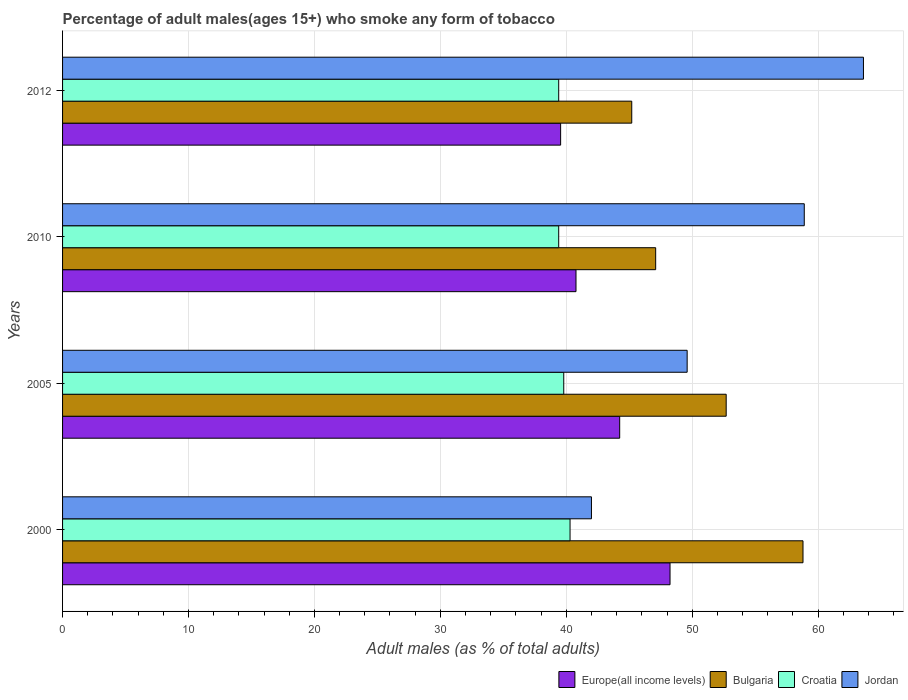How many different coloured bars are there?
Your answer should be very brief. 4. How many groups of bars are there?
Keep it short and to the point. 4. Are the number of bars per tick equal to the number of legend labels?
Your answer should be very brief. Yes. How many bars are there on the 4th tick from the bottom?
Your answer should be very brief. 4. What is the label of the 4th group of bars from the top?
Offer a terse response. 2000. In how many cases, is the number of bars for a given year not equal to the number of legend labels?
Ensure brevity in your answer.  0. What is the percentage of adult males who smoke in Bulgaria in 2000?
Keep it short and to the point. 58.8. Across all years, what is the maximum percentage of adult males who smoke in Europe(all income levels)?
Provide a short and direct response. 48.24. Across all years, what is the minimum percentage of adult males who smoke in Europe(all income levels)?
Provide a succinct answer. 39.55. In which year was the percentage of adult males who smoke in Croatia maximum?
Give a very brief answer. 2000. What is the total percentage of adult males who smoke in Jordan in the graph?
Offer a terse response. 214.1. What is the difference between the percentage of adult males who smoke in Bulgaria in 2005 and that in 2010?
Offer a very short reply. 5.6. What is the difference between the percentage of adult males who smoke in Jordan in 2010 and the percentage of adult males who smoke in Europe(all income levels) in 2005?
Give a very brief answer. 14.66. What is the average percentage of adult males who smoke in Europe(all income levels) per year?
Ensure brevity in your answer.  43.2. In the year 2005, what is the difference between the percentage of adult males who smoke in Bulgaria and percentage of adult males who smoke in Jordan?
Your answer should be very brief. 3.1. In how many years, is the percentage of adult males who smoke in Jordan greater than 60 %?
Your answer should be compact. 1. What is the ratio of the percentage of adult males who smoke in Europe(all income levels) in 2000 to that in 2012?
Your answer should be very brief. 1.22. Is the difference between the percentage of adult males who smoke in Bulgaria in 2000 and 2005 greater than the difference between the percentage of adult males who smoke in Jordan in 2000 and 2005?
Your answer should be very brief. Yes. What is the difference between the highest and the lowest percentage of adult males who smoke in Bulgaria?
Your answer should be compact. 13.6. In how many years, is the percentage of adult males who smoke in Bulgaria greater than the average percentage of adult males who smoke in Bulgaria taken over all years?
Offer a very short reply. 2. Is the sum of the percentage of adult males who smoke in Croatia in 2000 and 2005 greater than the maximum percentage of adult males who smoke in Jordan across all years?
Provide a succinct answer. Yes. Is it the case that in every year, the sum of the percentage of adult males who smoke in Jordan and percentage of adult males who smoke in Croatia is greater than the sum of percentage of adult males who smoke in Europe(all income levels) and percentage of adult males who smoke in Bulgaria?
Your answer should be compact. No. What does the 4th bar from the bottom in 2012 represents?
Your response must be concise. Jordan. Are all the bars in the graph horizontal?
Provide a succinct answer. Yes. How many legend labels are there?
Your response must be concise. 4. How are the legend labels stacked?
Offer a terse response. Horizontal. What is the title of the graph?
Your answer should be very brief. Percentage of adult males(ages 15+) who smoke any form of tobacco. Does "New Zealand" appear as one of the legend labels in the graph?
Your answer should be compact. No. What is the label or title of the X-axis?
Your answer should be very brief. Adult males (as % of total adults). What is the Adult males (as % of total adults) in Europe(all income levels) in 2000?
Your answer should be compact. 48.24. What is the Adult males (as % of total adults) in Bulgaria in 2000?
Your answer should be compact. 58.8. What is the Adult males (as % of total adults) in Croatia in 2000?
Your answer should be compact. 40.3. What is the Adult males (as % of total adults) in Jordan in 2000?
Offer a very short reply. 42. What is the Adult males (as % of total adults) of Europe(all income levels) in 2005?
Keep it short and to the point. 44.24. What is the Adult males (as % of total adults) in Bulgaria in 2005?
Provide a short and direct response. 52.7. What is the Adult males (as % of total adults) of Croatia in 2005?
Keep it short and to the point. 39.8. What is the Adult males (as % of total adults) in Jordan in 2005?
Offer a terse response. 49.6. What is the Adult males (as % of total adults) of Europe(all income levels) in 2010?
Your answer should be very brief. 40.77. What is the Adult males (as % of total adults) in Bulgaria in 2010?
Offer a terse response. 47.1. What is the Adult males (as % of total adults) of Croatia in 2010?
Provide a short and direct response. 39.4. What is the Adult males (as % of total adults) in Jordan in 2010?
Provide a short and direct response. 58.9. What is the Adult males (as % of total adults) of Europe(all income levels) in 2012?
Ensure brevity in your answer.  39.55. What is the Adult males (as % of total adults) in Bulgaria in 2012?
Ensure brevity in your answer.  45.2. What is the Adult males (as % of total adults) in Croatia in 2012?
Make the answer very short. 39.4. What is the Adult males (as % of total adults) of Jordan in 2012?
Keep it short and to the point. 63.6. Across all years, what is the maximum Adult males (as % of total adults) of Europe(all income levels)?
Offer a very short reply. 48.24. Across all years, what is the maximum Adult males (as % of total adults) of Bulgaria?
Provide a succinct answer. 58.8. Across all years, what is the maximum Adult males (as % of total adults) of Croatia?
Ensure brevity in your answer.  40.3. Across all years, what is the maximum Adult males (as % of total adults) of Jordan?
Ensure brevity in your answer.  63.6. Across all years, what is the minimum Adult males (as % of total adults) of Europe(all income levels)?
Your answer should be compact. 39.55. Across all years, what is the minimum Adult males (as % of total adults) in Bulgaria?
Give a very brief answer. 45.2. Across all years, what is the minimum Adult males (as % of total adults) in Croatia?
Your answer should be compact. 39.4. Across all years, what is the minimum Adult males (as % of total adults) of Jordan?
Keep it short and to the point. 42. What is the total Adult males (as % of total adults) of Europe(all income levels) in the graph?
Keep it short and to the point. 172.81. What is the total Adult males (as % of total adults) of Bulgaria in the graph?
Your answer should be very brief. 203.8. What is the total Adult males (as % of total adults) of Croatia in the graph?
Provide a short and direct response. 158.9. What is the total Adult males (as % of total adults) of Jordan in the graph?
Give a very brief answer. 214.1. What is the difference between the Adult males (as % of total adults) in Europe(all income levels) in 2000 and that in 2005?
Offer a terse response. 4. What is the difference between the Adult males (as % of total adults) in Bulgaria in 2000 and that in 2005?
Your answer should be very brief. 6.1. What is the difference between the Adult males (as % of total adults) of Croatia in 2000 and that in 2005?
Your answer should be compact. 0.5. What is the difference between the Adult males (as % of total adults) in Europe(all income levels) in 2000 and that in 2010?
Give a very brief answer. 7.47. What is the difference between the Adult males (as % of total adults) in Jordan in 2000 and that in 2010?
Offer a very short reply. -16.9. What is the difference between the Adult males (as % of total adults) in Europe(all income levels) in 2000 and that in 2012?
Your answer should be compact. 8.69. What is the difference between the Adult males (as % of total adults) of Jordan in 2000 and that in 2012?
Your response must be concise. -21.6. What is the difference between the Adult males (as % of total adults) of Europe(all income levels) in 2005 and that in 2010?
Make the answer very short. 3.47. What is the difference between the Adult males (as % of total adults) in Bulgaria in 2005 and that in 2010?
Your response must be concise. 5.6. What is the difference between the Adult males (as % of total adults) of Jordan in 2005 and that in 2010?
Give a very brief answer. -9.3. What is the difference between the Adult males (as % of total adults) in Europe(all income levels) in 2005 and that in 2012?
Make the answer very short. 4.69. What is the difference between the Adult males (as % of total adults) in Bulgaria in 2005 and that in 2012?
Provide a short and direct response. 7.5. What is the difference between the Adult males (as % of total adults) in Croatia in 2005 and that in 2012?
Your response must be concise. 0.4. What is the difference between the Adult males (as % of total adults) in Jordan in 2005 and that in 2012?
Provide a succinct answer. -14. What is the difference between the Adult males (as % of total adults) of Europe(all income levels) in 2010 and that in 2012?
Make the answer very short. 1.22. What is the difference between the Adult males (as % of total adults) in Croatia in 2010 and that in 2012?
Your answer should be compact. 0. What is the difference between the Adult males (as % of total adults) of Europe(all income levels) in 2000 and the Adult males (as % of total adults) of Bulgaria in 2005?
Ensure brevity in your answer.  -4.46. What is the difference between the Adult males (as % of total adults) in Europe(all income levels) in 2000 and the Adult males (as % of total adults) in Croatia in 2005?
Your answer should be very brief. 8.44. What is the difference between the Adult males (as % of total adults) in Europe(all income levels) in 2000 and the Adult males (as % of total adults) in Jordan in 2005?
Offer a very short reply. -1.36. What is the difference between the Adult males (as % of total adults) of Bulgaria in 2000 and the Adult males (as % of total adults) of Jordan in 2005?
Provide a succinct answer. 9.2. What is the difference between the Adult males (as % of total adults) of Croatia in 2000 and the Adult males (as % of total adults) of Jordan in 2005?
Keep it short and to the point. -9.3. What is the difference between the Adult males (as % of total adults) in Europe(all income levels) in 2000 and the Adult males (as % of total adults) in Bulgaria in 2010?
Ensure brevity in your answer.  1.14. What is the difference between the Adult males (as % of total adults) of Europe(all income levels) in 2000 and the Adult males (as % of total adults) of Croatia in 2010?
Ensure brevity in your answer.  8.84. What is the difference between the Adult males (as % of total adults) in Europe(all income levels) in 2000 and the Adult males (as % of total adults) in Jordan in 2010?
Offer a terse response. -10.66. What is the difference between the Adult males (as % of total adults) in Bulgaria in 2000 and the Adult males (as % of total adults) in Croatia in 2010?
Provide a succinct answer. 19.4. What is the difference between the Adult males (as % of total adults) of Bulgaria in 2000 and the Adult males (as % of total adults) of Jordan in 2010?
Keep it short and to the point. -0.1. What is the difference between the Adult males (as % of total adults) in Croatia in 2000 and the Adult males (as % of total adults) in Jordan in 2010?
Offer a very short reply. -18.6. What is the difference between the Adult males (as % of total adults) of Europe(all income levels) in 2000 and the Adult males (as % of total adults) of Bulgaria in 2012?
Ensure brevity in your answer.  3.04. What is the difference between the Adult males (as % of total adults) in Europe(all income levels) in 2000 and the Adult males (as % of total adults) in Croatia in 2012?
Your answer should be compact. 8.84. What is the difference between the Adult males (as % of total adults) of Europe(all income levels) in 2000 and the Adult males (as % of total adults) of Jordan in 2012?
Make the answer very short. -15.36. What is the difference between the Adult males (as % of total adults) in Bulgaria in 2000 and the Adult males (as % of total adults) in Croatia in 2012?
Make the answer very short. 19.4. What is the difference between the Adult males (as % of total adults) in Bulgaria in 2000 and the Adult males (as % of total adults) in Jordan in 2012?
Your response must be concise. -4.8. What is the difference between the Adult males (as % of total adults) in Croatia in 2000 and the Adult males (as % of total adults) in Jordan in 2012?
Your answer should be very brief. -23.3. What is the difference between the Adult males (as % of total adults) of Europe(all income levels) in 2005 and the Adult males (as % of total adults) of Bulgaria in 2010?
Make the answer very short. -2.86. What is the difference between the Adult males (as % of total adults) in Europe(all income levels) in 2005 and the Adult males (as % of total adults) in Croatia in 2010?
Provide a short and direct response. 4.84. What is the difference between the Adult males (as % of total adults) in Europe(all income levels) in 2005 and the Adult males (as % of total adults) in Jordan in 2010?
Your response must be concise. -14.66. What is the difference between the Adult males (as % of total adults) of Bulgaria in 2005 and the Adult males (as % of total adults) of Croatia in 2010?
Offer a terse response. 13.3. What is the difference between the Adult males (as % of total adults) in Bulgaria in 2005 and the Adult males (as % of total adults) in Jordan in 2010?
Your response must be concise. -6.2. What is the difference between the Adult males (as % of total adults) in Croatia in 2005 and the Adult males (as % of total adults) in Jordan in 2010?
Provide a short and direct response. -19.1. What is the difference between the Adult males (as % of total adults) in Europe(all income levels) in 2005 and the Adult males (as % of total adults) in Bulgaria in 2012?
Give a very brief answer. -0.96. What is the difference between the Adult males (as % of total adults) in Europe(all income levels) in 2005 and the Adult males (as % of total adults) in Croatia in 2012?
Offer a terse response. 4.84. What is the difference between the Adult males (as % of total adults) of Europe(all income levels) in 2005 and the Adult males (as % of total adults) of Jordan in 2012?
Offer a very short reply. -19.36. What is the difference between the Adult males (as % of total adults) in Bulgaria in 2005 and the Adult males (as % of total adults) in Croatia in 2012?
Provide a succinct answer. 13.3. What is the difference between the Adult males (as % of total adults) in Croatia in 2005 and the Adult males (as % of total adults) in Jordan in 2012?
Keep it short and to the point. -23.8. What is the difference between the Adult males (as % of total adults) in Europe(all income levels) in 2010 and the Adult males (as % of total adults) in Bulgaria in 2012?
Your response must be concise. -4.43. What is the difference between the Adult males (as % of total adults) in Europe(all income levels) in 2010 and the Adult males (as % of total adults) in Croatia in 2012?
Give a very brief answer. 1.37. What is the difference between the Adult males (as % of total adults) in Europe(all income levels) in 2010 and the Adult males (as % of total adults) in Jordan in 2012?
Provide a succinct answer. -22.83. What is the difference between the Adult males (as % of total adults) of Bulgaria in 2010 and the Adult males (as % of total adults) of Croatia in 2012?
Offer a terse response. 7.7. What is the difference between the Adult males (as % of total adults) of Bulgaria in 2010 and the Adult males (as % of total adults) of Jordan in 2012?
Offer a terse response. -16.5. What is the difference between the Adult males (as % of total adults) in Croatia in 2010 and the Adult males (as % of total adults) in Jordan in 2012?
Provide a succinct answer. -24.2. What is the average Adult males (as % of total adults) in Europe(all income levels) per year?
Keep it short and to the point. 43.2. What is the average Adult males (as % of total adults) of Bulgaria per year?
Your answer should be compact. 50.95. What is the average Adult males (as % of total adults) in Croatia per year?
Offer a very short reply. 39.73. What is the average Adult males (as % of total adults) in Jordan per year?
Your answer should be very brief. 53.52. In the year 2000, what is the difference between the Adult males (as % of total adults) in Europe(all income levels) and Adult males (as % of total adults) in Bulgaria?
Keep it short and to the point. -10.56. In the year 2000, what is the difference between the Adult males (as % of total adults) of Europe(all income levels) and Adult males (as % of total adults) of Croatia?
Offer a very short reply. 7.94. In the year 2000, what is the difference between the Adult males (as % of total adults) in Europe(all income levels) and Adult males (as % of total adults) in Jordan?
Your answer should be compact. 6.24. In the year 2000, what is the difference between the Adult males (as % of total adults) of Croatia and Adult males (as % of total adults) of Jordan?
Your response must be concise. -1.7. In the year 2005, what is the difference between the Adult males (as % of total adults) of Europe(all income levels) and Adult males (as % of total adults) of Bulgaria?
Provide a succinct answer. -8.46. In the year 2005, what is the difference between the Adult males (as % of total adults) of Europe(all income levels) and Adult males (as % of total adults) of Croatia?
Keep it short and to the point. 4.44. In the year 2005, what is the difference between the Adult males (as % of total adults) of Europe(all income levels) and Adult males (as % of total adults) of Jordan?
Make the answer very short. -5.36. In the year 2005, what is the difference between the Adult males (as % of total adults) of Bulgaria and Adult males (as % of total adults) of Jordan?
Make the answer very short. 3.1. In the year 2005, what is the difference between the Adult males (as % of total adults) in Croatia and Adult males (as % of total adults) in Jordan?
Ensure brevity in your answer.  -9.8. In the year 2010, what is the difference between the Adult males (as % of total adults) of Europe(all income levels) and Adult males (as % of total adults) of Bulgaria?
Your response must be concise. -6.33. In the year 2010, what is the difference between the Adult males (as % of total adults) in Europe(all income levels) and Adult males (as % of total adults) in Croatia?
Give a very brief answer. 1.37. In the year 2010, what is the difference between the Adult males (as % of total adults) of Europe(all income levels) and Adult males (as % of total adults) of Jordan?
Keep it short and to the point. -18.13. In the year 2010, what is the difference between the Adult males (as % of total adults) of Bulgaria and Adult males (as % of total adults) of Jordan?
Your response must be concise. -11.8. In the year 2010, what is the difference between the Adult males (as % of total adults) of Croatia and Adult males (as % of total adults) of Jordan?
Provide a short and direct response. -19.5. In the year 2012, what is the difference between the Adult males (as % of total adults) in Europe(all income levels) and Adult males (as % of total adults) in Bulgaria?
Give a very brief answer. -5.65. In the year 2012, what is the difference between the Adult males (as % of total adults) of Europe(all income levels) and Adult males (as % of total adults) of Croatia?
Offer a very short reply. 0.15. In the year 2012, what is the difference between the Adult males (as % of total adults) in Europe(all income levels) and Adult males (as % of total adults) in Jordan?
Your answer should be very brief. -24.05. In the year 2012, what is the difference between the Adult males (as % of total adults) in Bulgaria and Adult males (as % of total adults) in Jordan?
Your answer should be compact. -18.4. In the year 2012, what is the difference between the Adult males (as % of total adults) in Croatia and Adult males (as % of total adults) in Jordan?
Provide a succinct answer. -24.2. What is the ratio of the Adult males (as % of total adults) of Europe(all income levels) in 2000 to that in 2005?
Offer a very short reply. 1.09. What is the ratio of the Adult males (as % of total adults) in Bulgaria in 2000 to that in 2005?
Offer a very short reply. 1.12. What is the ratio of the Adult males (as % of total adults) in Croatia in 2000 to that in 2005?
Your answer should be compact. 1.01. What is the ratio of the Adult males (as % of total adults) of Jordan in 2000 to that in 2005?
Ensure brevity in your answer.  0.85. What is the ratio of the Adult males (as % of total adults) in Europe(all income levels) in 2000 to that in 2010?
Your answer should be very brief. 1.18. What is the ratio of the Adult males (as % of total adults) of Bulgaria in 2000 to that in 2010?
Your answer should be compact. 1.25. What is the ratio of the Adult males (as % of total adults) in Croatia in 2000 to that in 2010?
Make the answer very short. 1.02. What is the ratio of the Adult males (as % of total adults) in Jordan in 2000 to that in 2010?
Keep it short and to the point. 0.71. What is the ratio of the Adult males (as % of total adults) of Europe(all income levels) in 2000 to that in 2012?
Your answer should be compact. 1.22. What is the ratio of the Adult males (as % of total adults) in Bulgaria in 2000 to that in 2012?
Provide a short and direct response. 1.3. What is the ratio of the Adult males (as % of total adults) of Croatia in 2000 to that in 2012?
Offer a very short reply. 1.02. What is the ratio of the Adult males (as % of total adults) of Jordan in 2000 to that in 2012?
Your answer should be compact. 0.66. What is the ratio of the Adult males (as % of total adults) in Europe(all income levels) in 2005 to that in 2010?
Your response must be concise. 1.09. What is the ratio of the Adult males (as % of total adults) of Bulgaria in 2005 to that in 2010?
Provide a succinct answer. 1.12. What is the ratio of the Adult males (as % of total adults) of Croatia in 2005 to that in 2010?
Your answer should be very brief. 1.01. What is the ratio of the Adult males (as % of total adults) of Jordan in 2005 to that in 2010?
Your answer should be compact. 0.84. What is the ratio of the Adult males (as % of total adults) in Europe(all income levels) in 2005 to that in 2012?
Offer a terse response. 1.12. What is the ratio of the Adult males (as % of total adults) of Bulgaria in 2005 to that in 2012?
Keep it short and to the point. 1.17. What is the ratio of the Adult males (as % of total adults) of Croatia in 2005 to that in 2012?
Your answer should be very brief. 1.01. What is the ratio of the Adult males (as % of total adults) of Jordan in 2005 to that in 2012?
Offer a terse response. 0.78. What is the ratio of the Adult males (as % of total adults) of Europe(all income levels) in 2010 to that in 2012?
Provide a succinct answer. 1.03. What is the ratio of the Adult males (as % of total adults) in Bulgaria in 2010 to that in 2012?
Ensure brevity in your answer.  1.04. What is the ratio of the Adult males (as % of total adults) in Croatia in 2010 to that in 2012?
Keep it short and to the point. 1. What is the ratio of the Adult males (as % of total adults) of Jordan in 2010 to that in 2012?
Keep it short and to the point. 0.93. What is the difference between the highest and the second highest Adult males (as % of total adults) of Europe(all income levels)?
Your answer should be compact. 4. What is the difference between the highest and the second highest Adult males (as % of total adults) in Croatia?
Your answer should be compact. 0.5. What is the difference between the highest and the second highest Adult males (as % of total adults) of Jordan?
Make the answer very short. 4.7. What is the difference between the highest and the lowest Adult males (as % of total adults) of Europe(all income levels)?
Ensure brevity in your answer.  8.69. What is the difference between the highest and the lowest Adult males (as % of total adults) of Jordan?
Offer a terse response. 21.6. 